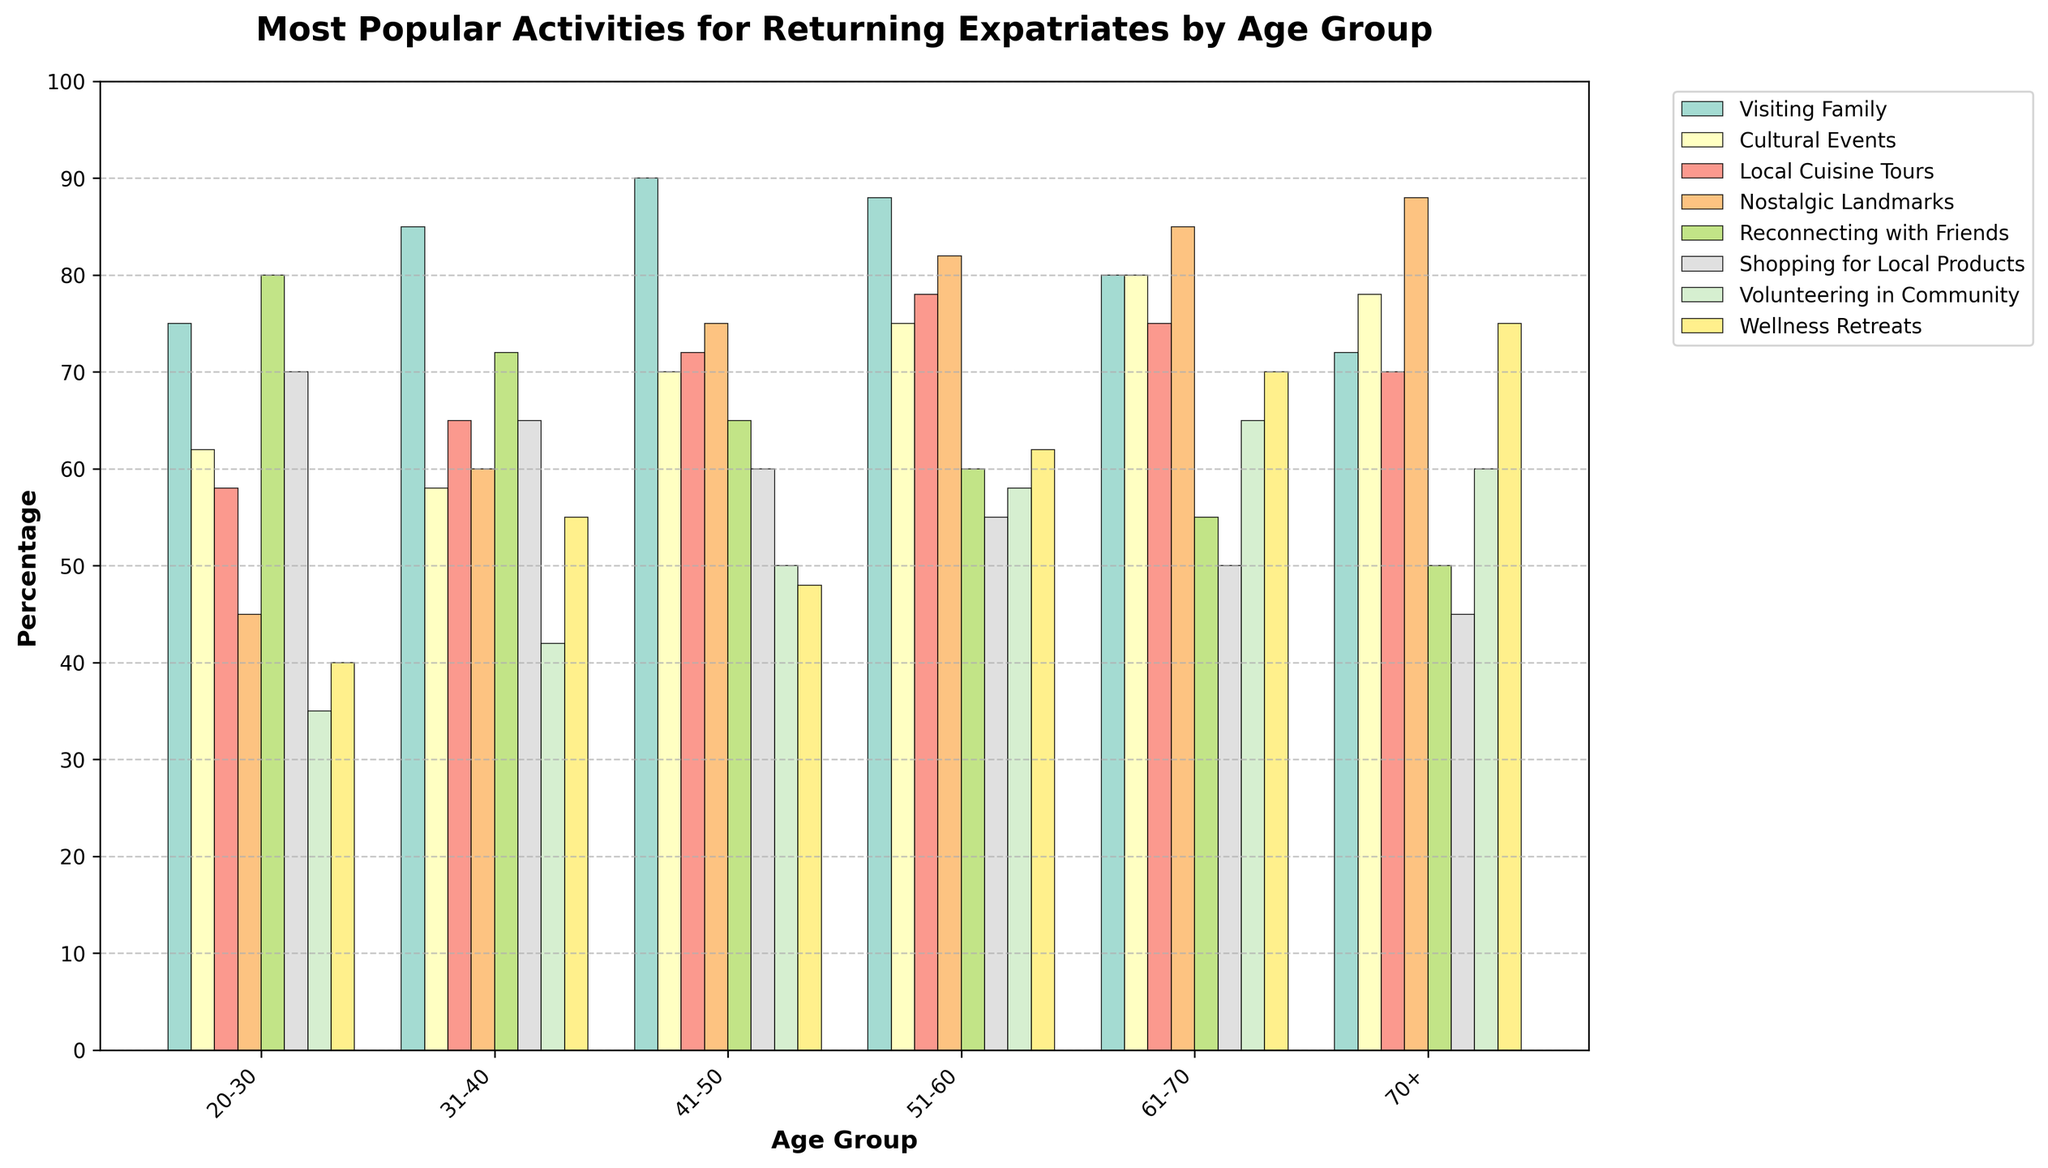Which age group participates in the most cultural events? To determine the age group that participates most in cultural events, look at the height of the bars representing Cultural Events for each age group. The '61-70' age group has the tallest bar for Cultural Events at 80%.
Answer: 61-70 What is the difference in percentage between 'Visiting Family' activities for the age groups 31-40 and 41-50? The percentage for 'Visiting Family' in the '31-40' age group is 85%, and for the '41-50' age group, it is 90%. The difference is 90% - 85% = 5%.
Answer: 5% Which activity is least popular in the '20-30' age group? To determine the least popular activity, check the height of the bars for the '20-30' age group. The shortest bar corresponds to 'Volunteering in Community' at 35%.
Answer: Volunteering in Community How many more people aged 51-60 prefer 'Wellness Retreats' than those aged 20-30 who prefer the same activity? The percentage for 'Wellness Retreats' in the '51-60' age group is 62%, and for the '20-30' age group, it is 40%. The difference is 62% - 40% = 22%.
Answer: 22% Which age group's favorite activity is 'Nostalgic Landmarks'? By examining the highest bar height for 'Nostalgic Landmarks', the '70+' age group has the tallest bar at 88%, indicating it's their favorite activity in this group.
Answer: 70+ Compare the participation in 'Shopping for Local Products' between age groups 41-50 and 61-70. Which group has more participants? For 'Shopping for Local Products', '41-50' has 60% and '61-70' has 50%. The '41-50' age group has higher participation.
Answer: 41-50 What is the average percentage of people engaging in 'Reconnecting with Friends' across all age groups? Add the percentages of 'Reconnecting with Friends' across all age groups: 80% + 72% + 65% + 60% + 55% + 50% = 382%. Then divide by the number of age groups (6). 382 / 6 ≈ 63.7%.
Answer: 63.7% How does the participation in 'Volunteering in Community' in the 51-60 age group compare to the 20-30 age group? For 'Volunteering in Community', the '51-60' age group has 58% participation, while the '20-30' age group has 35% participation. Thus, the '51-60' age group has higher participation.
Answer: 51-60 What is the combined percentage of people aged 61-70 participating in 'Wellness Retreats' and 'Nostalgic Landmarks'? The '61-70' age group has 70% in 'Wellness Retreats' and 85% in 'Nostalgic Landmarks'. The combined percentage is 70% + 85% = 155%.
Answer: 155% Which age group shows an equal level of participation in both 'Cultural Events' and 'Local Cuisine Tours'? By comparing the bars for 'Cultural Events' and 'Local Cuisine Tours' for each age group, the '61-70' age group shows equal participation at 75% for both activities.
Answer: 61-70 